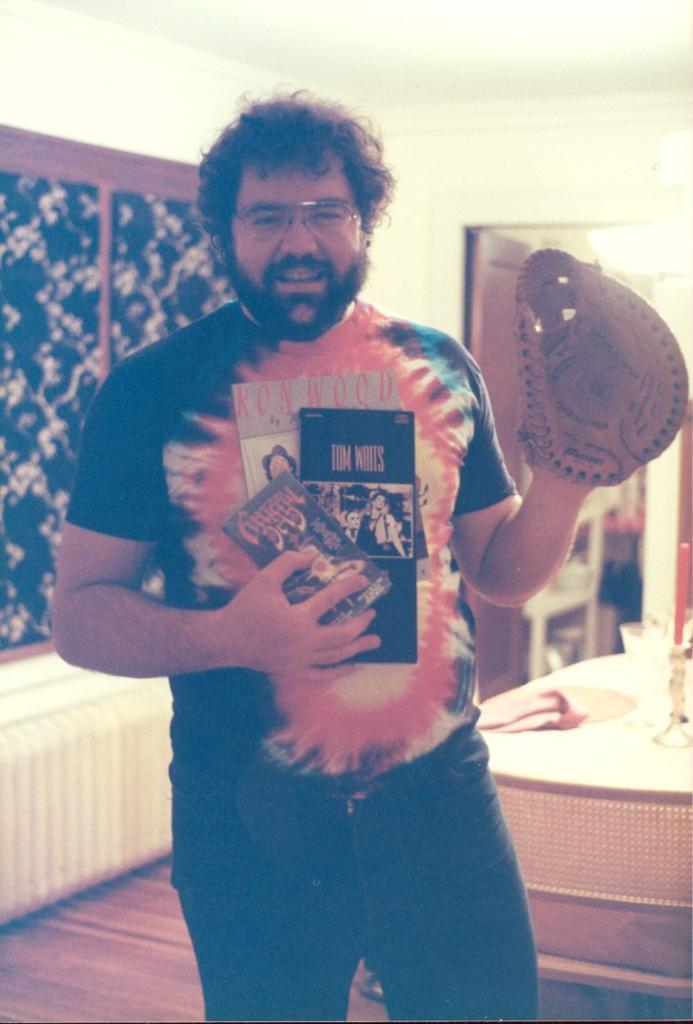Describe this image in one or two sentences. In the center of the image a man is standing and holding a books and wearing a glove. On the left side of the image wall is there. On the right side of the image there is a table. On the table we can see glass, cloth are present. At the bottom right corner chair is present. At the top of the image roof is there. Door is present on the right side of the image. 